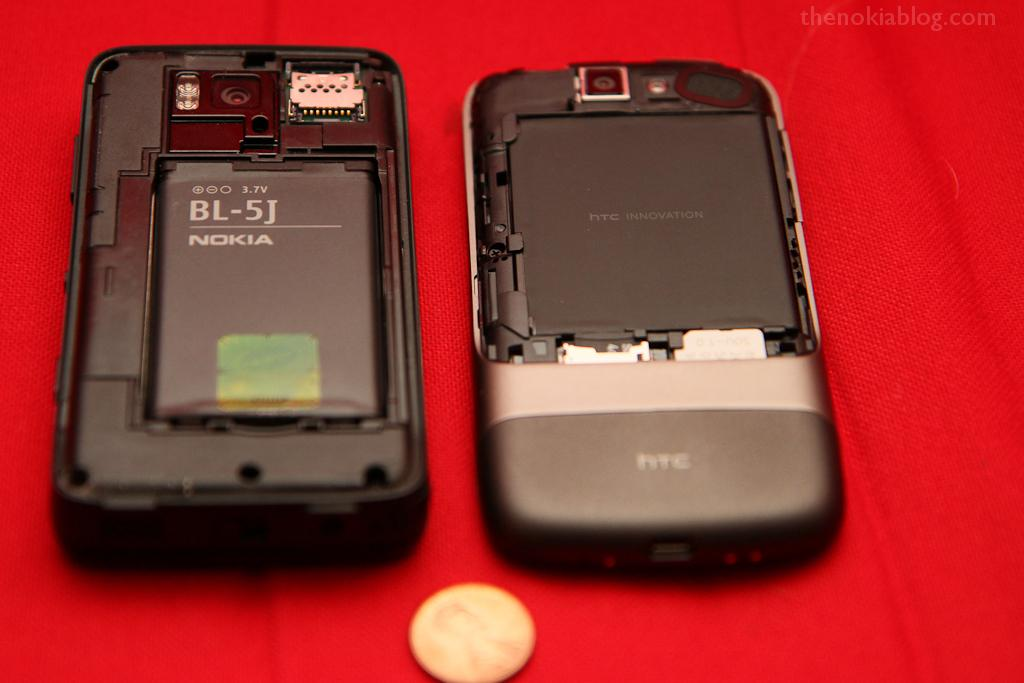<image>
Present a compact description of the photo's key features. A nokia and an htc phone sitting on a red table 